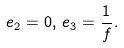Convert formula to latex. <formula><loc_0><loc_0><loc_500><loc_500>e _ { 2 } = 0 , \, e _ { 3 } = \frac { 1 } { f } .</formula> 